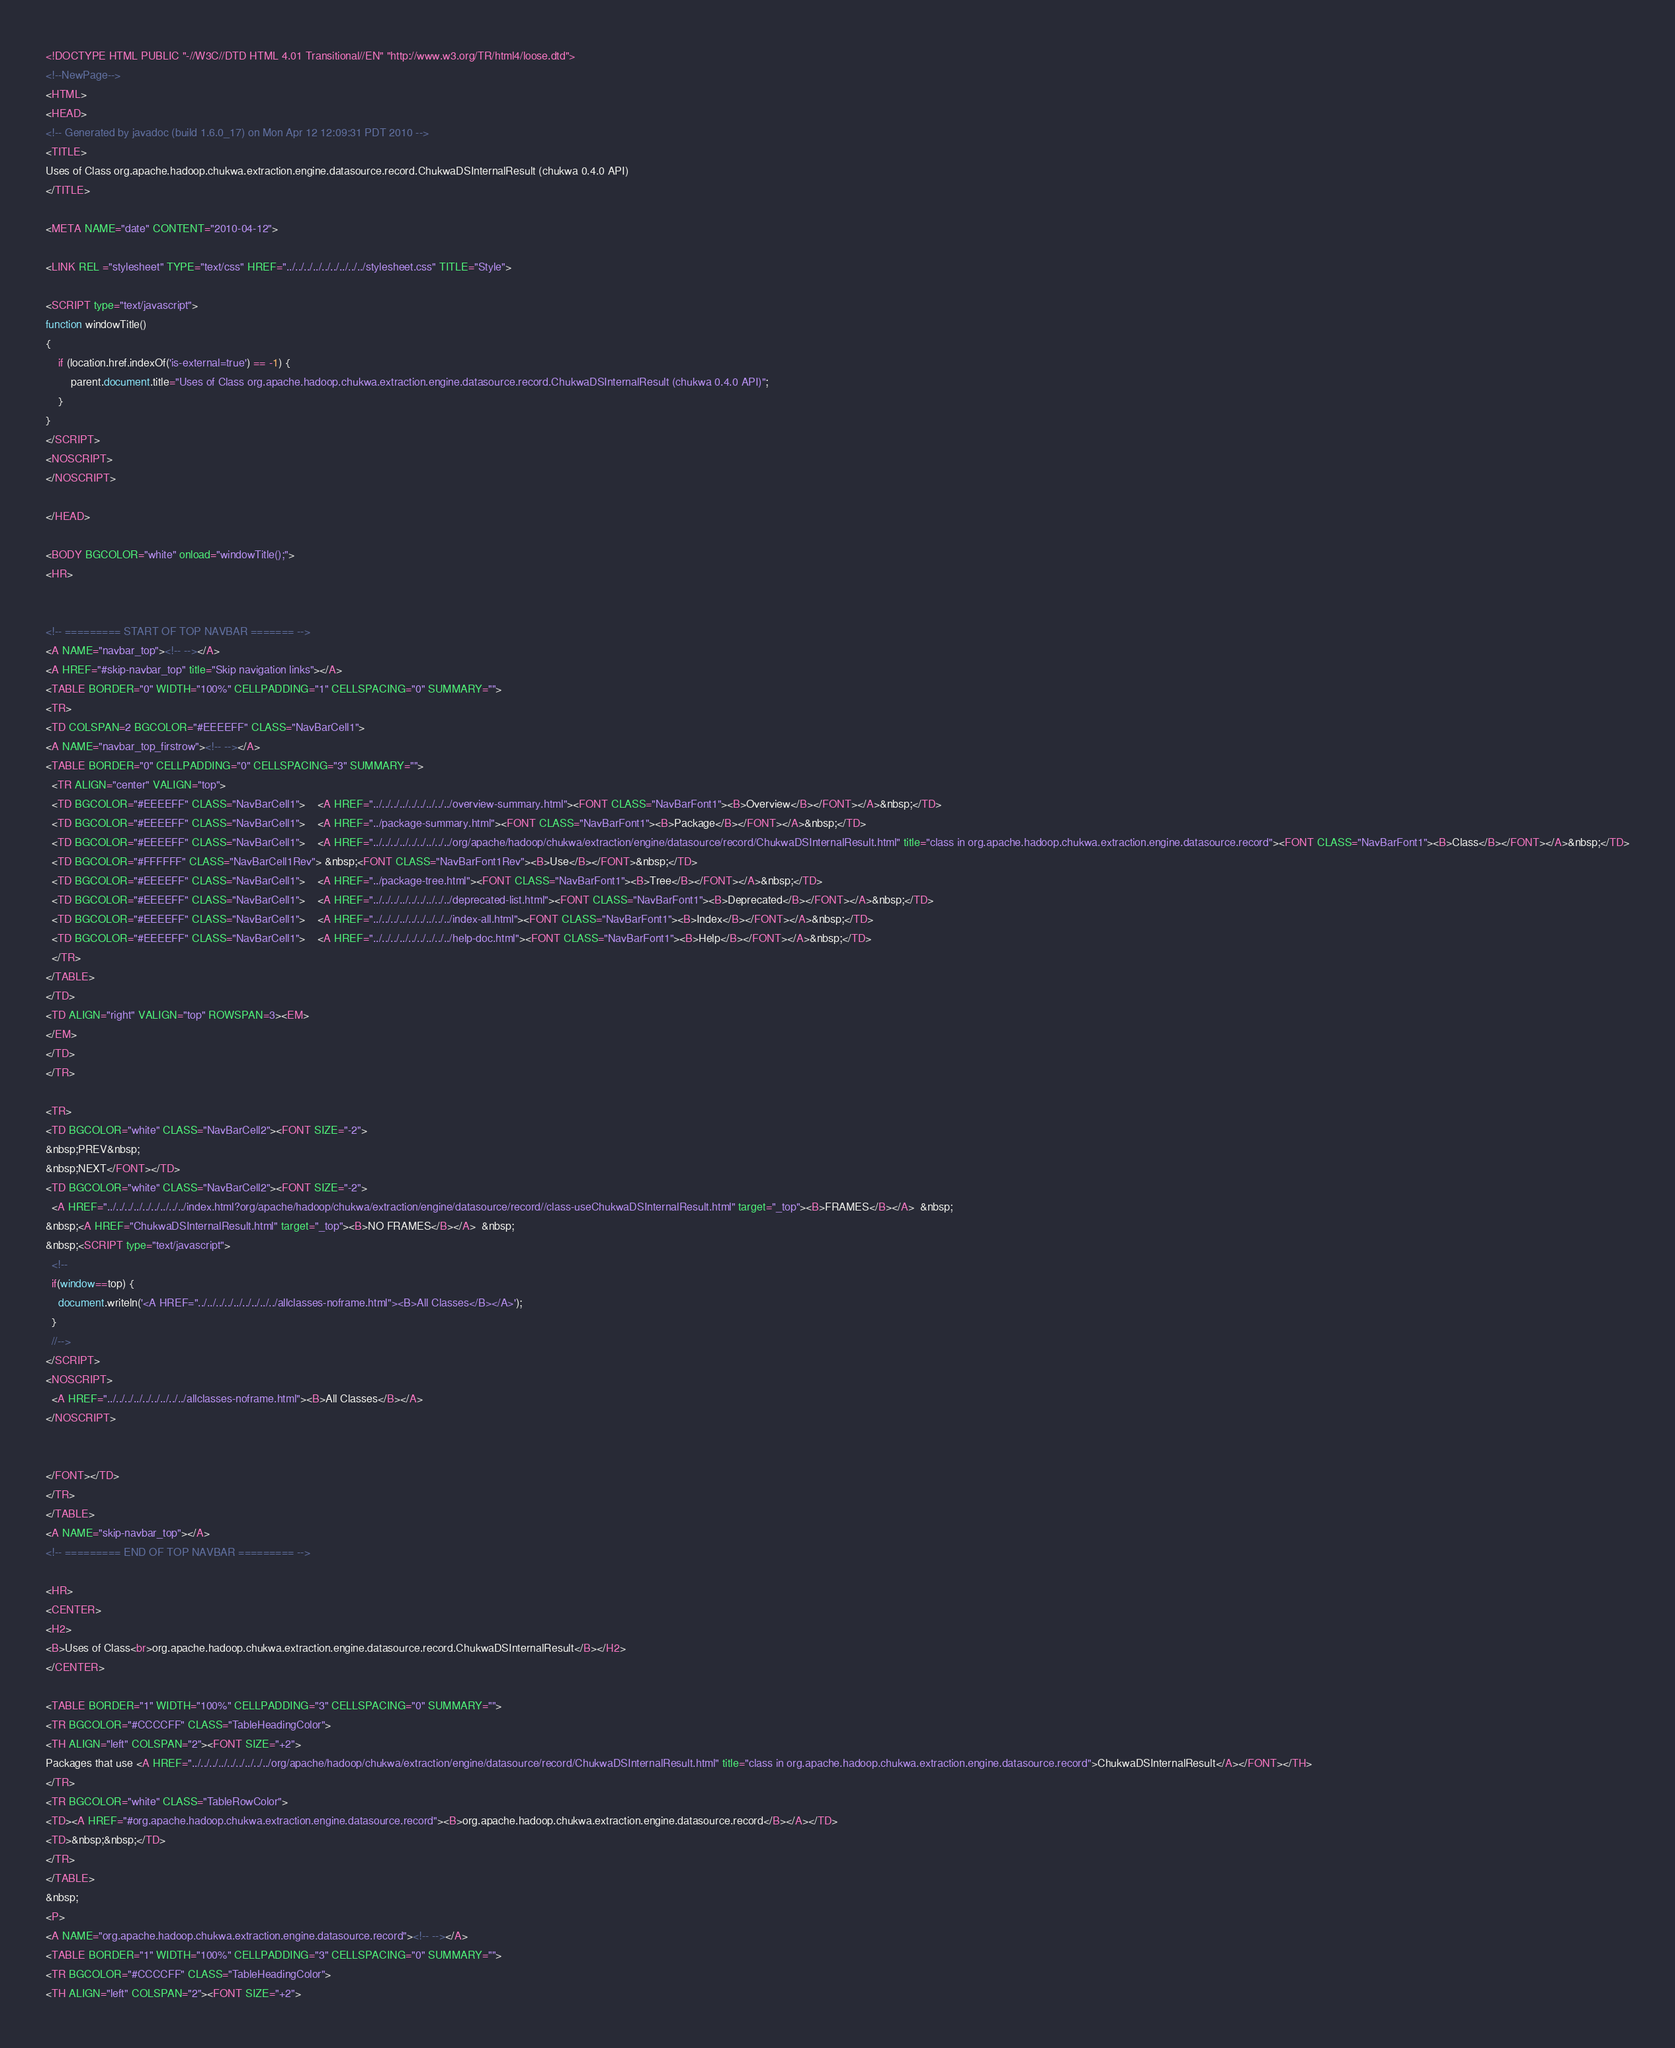Convert code to text. <code><loc_0><loc_0><loc_500><loc_500><_HTML_><!DOCTYPE HTML PUBLIC "-//W3C//DTD HTML 4.01 Transitional//EN" "http://www.w3.org/TR/html4/loose.dtd">
<!--NewPage-->
<HTML>
<HEAD>
<!-- Generated by javadoc (build 1.6.0_17) on Mon Apr 12 12:09:31 PDT 2010 -->
<TITLE>
Uses of Class org.apache.hadoop.chukwa.extraction.engine.datasource.record.ChukwaDSInternalResult (chukwa 0.4.0 API)
</TITLE>

<META NAME="date" CONTENT="2010-04-12">

<LINK REL ="stylesheet" TYPE="text/css" HREF="../../../../../../../../../stylesheet.css" TITLE="Style">

<SCRIPT type="text/javascript">
function windowTitle()
{
    if (location.href.indexOf('is-external=true') == -1) {
        parent.document.title="Uses of Class org.apache.hadoop.chukwa.extraction.engine.datasource.record.ChukwaDSInternalResult (chukwa 0.4.0 API)";
    }
}
</SCRIPT>
<NOSCRIPT>
</NOSCRIPT>

</HEAD>

<BODY BGCOLOR="white" onload="windowTitle();">
<HR>


<!-- ========= START OF TOP NAVBAR ======= -->
<A NAME="navbar_top"><!-- --></A>
<A HREF="#skip-navbar_top" title="Skip navigation links"></A>
<TABLE BORDER="0" WIDTH="100%" CELLPADDING="1" CELLSPACING="0" SUMMARY="">
<TR>
<TD COLSPAN=2 BGCOLOR="#EEEEFF" CLASS="NavBarCell1">
<A NAME="navbar_top_firstrow"><!-- --></A>
<TABLE BORDER="0" CELLPADDING="0" CELLSPACING="3" SUMMARY="">
  <TR ALIGN="center" VALIGN="top">
  <TD BGCOLOR="#EEEEFF" CLASS="NavBarCell1">    <A HREF="../../../../../../../../../overview-summary.html"><FONT CLASS="NavBarFont1"><B>Overview</B></FONT></A>&nbsp;</TD>
  <TD BGCOLOR="#EEEEFF" CLASS="NavBarCell1">    <A HREF="../package-summary.html"><FONT CLASS="NavBarFont1"><B>Package</B></FONT></A>&nbsp;</TD>
  <TD BGCOLOR="#EEEEFF" CLASS="NavBarCell1">    <A HREF="../../../../../../../../../org/apache/hadoop/chukwa/extraction/engine/datasource/record/ChukwaDSInternalResult.html" title="class in org.apache.hadoop.chukwa.extraction.engine.datasource.record"><FONT CLASS="NavBarFont1"><B>Class</B></FONT></A>&nbsp;</TD>
  <TD BGCOLOR="#FFFFFF" CLASS="NavBarCell1Rev"> &nbsp;<FONT CLASS="NavBarFont1Rev"><B>Use</B></FONT>&nbsp;</TD>
  <TD BGCOLOR="#EEEEFF" CLASS="NavBarCell1">    <A HREF="../package-tree.html"><FONT CLASS="NavBarFont1"><B>Tree</B></FONT></A>&nbsp;</TD>
  <TD BGCOLOR="#EEEEFF" CLASS="NavBarCell1">    <A HREF="../../../../../../../../../deprecated-list.html"><FONT CLASS="NavBarFont1"><B>Deprecated</B></FONT></A>&nbsp;</TD>
  <TD BGCOLOR="#EEEEFF" CLASS="NavBarCell1">    <A HREF="../../../../../../../../../index-all.html"><FONT CLASS="NavBarFont1"><B>Index</B></FONT></A>&nbsp;</TD>
  <TD BGCOLOR="#EEEEFF" CLASS="NavBarCell1">    <A HREF="../../../../../../../../../help-doc.html"><FONT CLASS="NavBarFont1"><B>Help</B></FONT></A>&nbsp;</TD>
  </TR>
</TABLE>
</TD>
<TD ALIGN="right" VALIGN="top" ROWSPAN=3><EM>
</EM>
</TD>
</TR>

<TR>
<TD BGCOLOR="white" CLASS="NavBarCell2"><FONT SIZE="-2">
&nbsp;PREV&nbsp;
&nbsp;NEXT</FONT></TD>
<TD BGCOLOR="white" CLASS="NavBarCell2"><FONT SIZE="-2">
  <A HREF="../../../../../../../../../index.html?org/apache/hadoop/chukwa/extraction/engine/datasource/record//class-useChukwaDSInternalResult.html" target="_top"><B>FRAMES</B></A>  &nbsp;
&nbsp;<A HREF="ChukwaDSInternalResult.html" target="_top"><B>NO FRAMES</B></A>  &nbsp;
&nbsp;<SCRIPT type="text/javascript">
  <!--
  if(window==top) {
    document.writeln('<A HREF="../../../../../../../../../allclasses-noframe.html"><B>All Classes</B></A>');
  }
  //-->
</SCRIPT>
<NOSCRIPT>
  <A HREF="../../../../../../../../../allclasses-noframe.html"><B>All Classes</B></A>
</NOSCRIPT>


</FONT></TD>
</TR>
</TABLE>
<A NAME="skip-navbar_top"></A>
<!-- ========= END OF TOP NAVBAR ========= -->

<HR>
<CENTER>
<H2>
<B>Uses of Class<br>org.apache.hadoop.chukwa.extraction.engine.datasource.record.ChukwaDSInternalResult</B></H2>
</CENTER>

<TABLE BORDER="1" WIDTH="100%" CELLPADDING="3" CELLSPACING="0" SUMMARY="">
<TR BGCOLOR="#CCCCFF" CLASS="TableHeadingColor">
<TH ALIGN="left" COLSPAN="2"><FONT SIZE="+2">
Packages that use <A HREF="../../../../../../../../../org/apache/hadoop/chukwa/extraction/engine/datasource/record/ChukwaDSInternalResult.html" title="class in org.apache.hadoop.chukwa.extraction.engine.datasource.record">ChukwaDSInternalResult</A></FONT></TH>
</TR>
<TR BGCOLOR="white" CLASS="TableRowColor">
<TD><A HREF="#org.apache.hadoop.chukwa.extraction.engine.datasource.record"><B>org.apache.hadoop.chukwa.extraction.engine.datasource.record</B></A></TD>
<TD>&nbsp;&nbsp;</TD>
</TR>
</TABLE>
&nbsp;
<P>
<A NAME="org.apache.hadoop.chukwa.extraction.engine.datasource.record"><!-- --></A>
<TABLE BORDER="1" WIDTH="100%" CELLPADDING="3" CELLSPACING="0" SUMMARY="">
<TR BGCOLOR="#CCCCFF" CLASS="TableHeadingColor">
<TH ALIGN="left" COLSPAN="2"><FONT SIZE="+2"></code> 